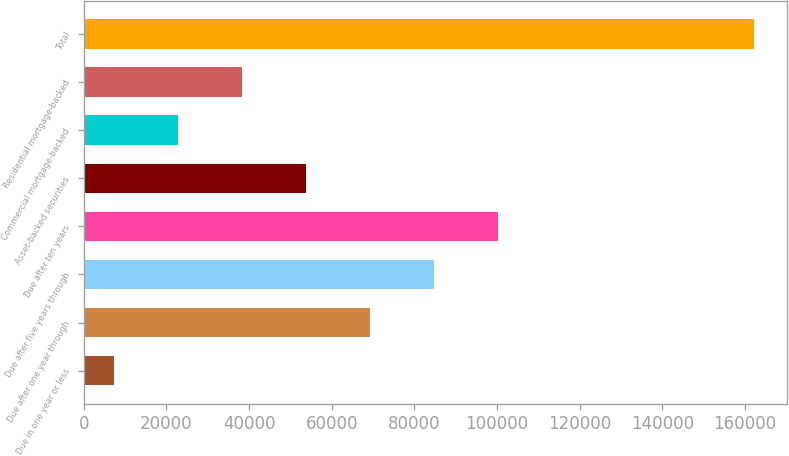Convert chart to OTSL. <chart><loc_0><loc_0><loc_500><loc_500><bar_chart><fcel>Due in one year or less<fcel>Due after one year through<fcel>Due after five years through<fcel>Due after ten years<fcel>Asset-backed securities<fcel>Commercial mortgage-backed<fcel>Residential mortgage-backed<fcel>Total<nl><fcel>7269<fcel>69226.2<fcel>84715.5<fcel>100205<fcel>53736.9<fcel>22758.3<fcel>38247.6<fcel>162162<nl></chart> 